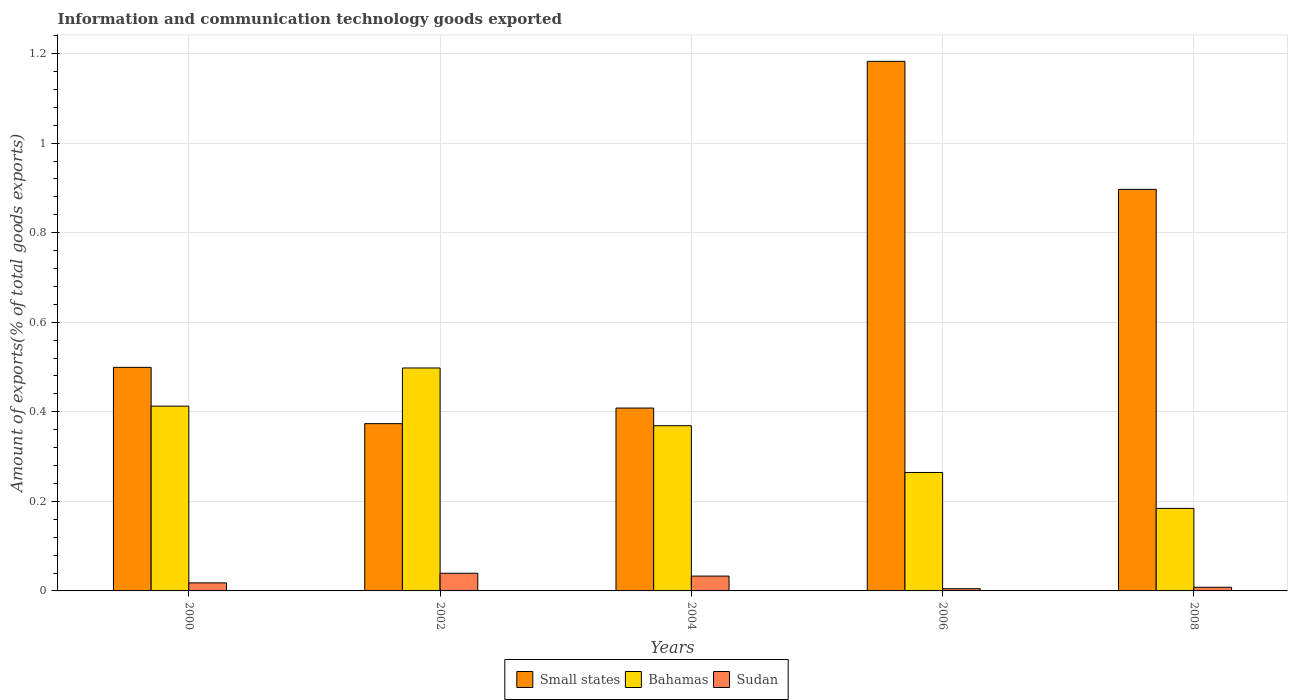Are the number of bars per tick equal to the number of legend labels?
Provide a short and direct response. Yes. In how many cases, is the number of bars for a given year not equal to the number of legend labels?
Provide a short and direct response. 0. What is the amount of goods exported in Small states in 2002?
Your response must be concise. 0.37. Across all years, what is the maximum amount of goods exported in Bahamas?
Give a very brief answer. 0.5. Across all years, what is the minimum amount of goods exported in Small states?
Give a very brief answer. 0.37. What is the total amount of goods exported in Small states in the graph?
Make the answer very short. 3.36. What is the difference between the amount of goods exported in Small states in 2002 and that in 2008?
Offer a terse response. -0.52. What is the difference between the amount of goods exported in Small states in 2000 and the amount of goods exported in Sudan in 2006?
Make the answer very short. 0.49. What is the average amount of goods exported in Sudan per year?
Ensure brevity in your answer.  0.02. In the year 2008, what is the difference between the amount of goods exported in Sudan and amount of goods exported in Small states?
Provide a succinct answer. -0.89. In how many years, is the amount of goods exported in Sudan greater than 0.6000000000000001 %?
Your answer should be compact. 0. What is the ratio of the amount of goods exported in Bahamas in 2000 to that in 2006?
Provide a short and direct response. 1.56. Is the amount of goods exported in Small states in 2000 less than that in 2008?
Your response must be concise. Yes. What is the difference between the highest and the second highest amount of goods exported in Bahamas?
Your answer should be compact. 0.09. What is the difference between the highest and the lowest amount of goods exported in Bahamas?
Your answer should be compact. 0.31. In how many years, is the amount of goods exported in Small states greater than the average amount of goods exported in Small states taken over all years?
Your response must be concise. 2. Is the sum of the amount of goods exported in Bahamas in 2002 and 2008 greater than the maximum amount of goods exported in Sudan across all years?
Offer a very short reply. Yes. What does the 1st bar from the left in 2004 represents?
Provide a short and direct response. Small states. What does the 2nd bar from the right in 2000 represents?
Offer a very short reply. Bahamas. Is it the case that in every year, the sum of the amount of goods exported in Sudan and amount of goods exported in Bahamas is greater than the amount of goods exported in Small states?
Provide a succinct answer. No. Are all the bars in the graph horizontal?
Your answer should be very brief. No. How many years are there in the graph?
Provide a short and direct response. 5. What is the difference between two consecutive major ticks on the Y-axis?
Your response must be concise. 0.2. Are the values on the major ticks of Y-axis written in scientific E-notation?
Keep it short and to the point. No. How are the legend labels stacked?
Keep it short and to the point. Horizontal. What is the title of the graph?
Your response must be concise. Information and communication technology goods exported. What is the label or title of the Y-axis?
Offer a terse response. Amount of exports(% of total goods exports). What is the Amount of exports(% of total goods exports) in Small states in 2000?
Your answer should be compact. 0.5. What is the Amount of exports(% of total goods exports) in Bahamas in 2000?
Provide a short and direct response. 0.41. What is the Amount of exports(% of total goods exports) in Sudan in 2000?
Offer a very short reply. 0.02. What is the Amount of exports(% of total goods exports) of Small states in 2002?
Offer a very short reply. 0.37. What is the Amount of exports(% of total goods exports) of Bahamas in 2002?
Give a very brief answer. 0.5. What is the Amount of exports(% of total goods exports) of Sudan in 2002?
Offer a very short reply. 0.04. What is the Amount of exports(% of total goods exports) of Small states in 2004?
Provide a succinct answer. 0.41. What is the Amount of exports(% of total goods exports) of Bahamas in 2004?
Provide a succinct answer. 0.37. What is the Amount of exports(% of total goods exports) of Sudan in 2004?
Offer a terse response. 0.03. What is the Amount of exports(% of total goods exports) of Small states in 2006?
Your answer should be compact. 1.18. What is the Amount of exports(% of total goods exports) in Bahamas in 2006?
Your answer should be very brief. 0.26. What is the Amount of exports(% of total goods exports) of Sudan in 2006?
Offer a terse response. 0. What is the Amount of exports(% of total goods exports) of Small states in 2008?
Provide a short and direct response. 0.9. What is the Amount of exports(% of total goods exports) of Bahamas in 2008?
Make the answer very short. 0.18. What is the Amount of exports(% of total goods exports) of Sudan in 2008?
Give a very brief answer. 0.01. Across all years, what is the maximum Amount of exports(% of total goods exports) in Small states?
Offer a terse response. 1.18. Across all years, what is the maximum Amount of exports(% of total goods exports) of Bahamas?
Offer a terse response. 0.5. Across all years, what is the maximum Amount of exports(% of total goods exports) in Sudan?
Keep it short and to the point. 0.04. Across all years, what is the minimum Amount of exports(% of total goods exports) in Small states?
Your answer should be very brief. 0.37. Across all years, what is the minimum Amount of exports(% of total goods exports) in Bahamas?
Your response must be concise. 0.18. Across all years, what is the minimum Amount of exports(% of total goods exports) of Sudan?
Ensure brevity in your answer.  0. What is the total Amount of exports(% of total goods exports) in Small states in the graph?
Offer a very short reply. 3.36. What is the total Amount of exports(% of total goods exports) of Bahamas in the graph?
Your answer should be very brief. 1.73. What is the total Amount of exports(% of total goods exports) of Sudan in the graph?
Provide a short and direct response. 0.1. What is the difference between the Amount of exports(% of total goods exports) of Small states in 2000 and that in 2002?
Ensure brevity in your answer.  0.13. What is the difference between the Amount of exports(% of total goods exports) of Bahamas in 2000 and that in 2002?
Offer a very short reply. -0.09. What is the difference between the Amount of exports(% of total goods exports) of Sudan in 2000 and that in 2002?
Ensure brevity in your answer.  -0.02. What is the difference between the Amount of exports(% of total goods exports) in Small states in 2000 and that in 2004?
Provide a short and direct response. 0.09. What is the difference between the Amount of exports(% of total goods exports) of Bahamas in 2000 and that in 2004?
Keep it short and to the point. 0.04. What is the difference between the Amount of exports(% of total goods exports) in Sudan in 2000 and that in 2004?
Ensure brevity in your answer.  -0.02. What is the difference between the Amount of exports(% of total goods exports) in Small states in 2000 and that in 2006?
Ensure brevity in your answer.  -0.68. What is the difference between the Amount of exports(% of total goods exports) in Bahamas in 2000 and that in 2006?
Make the answer very short. 0.15. What is the difference between the Amount of exports(% of total goods exports) of Sudan in 2000 and that in 2006?
Keep it short and to the point. 0.01. What is the difference between the Amount of exports(% of total goods exports) of Small states in 2000 and that in 2008?
Your response must be concise. -0.4. What is the difference between the Amount of exports(% of total goods exports) in Bahamas in 2000 and that in 2008?
Provide a succinct answer. 0.23. What is the difference between the Amount of exports(% of total goods exports) of Sudan in 2000 and that in 2008?
Make the answer very short. 0.01. What is the difference between the Amount of exports(% of total goods exports) in Small states in 2002 and that in 2004?
Offer a very short reply. -0.03. What is the difference between the Amount of exports(% of total goods exports) of Bahamas in 2002 and that in 2004?
Offer a very short reply. 0.13. What is the difference between the Amount of exports(% of total goods exports) in Sudan in 2002 and that in 2004?
Your answer should be very brief. 0.01. What is the difference between the Amount of exports(% of total goods exports) in Small states in 2002 and that in 2006?
Provide a succinct answer. -0.81. What is the difference between the Amount of exports(% of total goods exports) of Bahamas in 2002 and that in 2006?
Offer a very short reply. 0.23. What is the difference between the Amount of exports(% of total goods exports) in Sudan in 2002 and that in 2006?
Provide a short and direct response. 0.03. What is the difference between the Amount of exports(% of total goods exports) of Small states in 2002 and that in 2008?
Offer a terse response. -0.52. What is the difference between the Amount of exports(% of total goods exports) in Bahamas in 2002 and that in 2008?
Keep it short and to the point. 0.31. What is the difference between the Amount of exports(% of total goods exports) of Sudan in 2002 and that in 2008?
Keep it short and to the point. 0.03. What is the difference between the Amount of exports(% of total goods exports) in Small states in 2004 and that in 2006?
Make the answer very short. -0.77. What is the difference between the Amount of exports(% of total goods exports) of Bahamas in 2004 and that in 2006?
Offer a terse response. 0.1. What is the difference between the Amount of exports(% of total goods exports) in Sudan in 2004 and that in 2006?
Offer a terse response. 0.03. What is the difference between the Amount of exports(% of total goods exports) of Small states in 2004 and that in 2008?
Provide a short and direct response. -0.49. What is the difference between the Amount of exports(% of total goods exports) of Bahamas in 2004 and that in 2008?
Offer a very short reply. 0.18. What is the difference between the Amount of exports(% of total goods exports) of Sudan in 2004 and that in 2008?
Offer a very short reply. 0.03. What is the difference between the Amount of exports(% of total goods exports) of Small states in 2006 and that in 2008?
Offer a very short reply. 0.29. What is the difference between the Amount of exports(% of total goods exports) in Bahamas in 2006 and that in 2008?
Offer a very short reply. 0.08. What is the difference between the Amount of exports(% of total goods exports) in Sudan in 2006 and that in 2008?
Offer a terse response. -0. What is the difference between the Amount of exports(% of total goods exports) in Small states in 2000 and the Amount of exports(% of total goods exports) in Bahamas in 2002?
Your response must be concise. 0. What is the difference between the Amount of exports(% of total goods exports) of Small states in 2000 and the Amount of exports(% of total goods exports) of Sudan in 2002?
Make the answer very short. 0.46. What is the difference between the Amount of exports(% of total goods exports) of Bahamas in 2000 and the Amount of exports(% of total goods exports) of Sudan in 2002?
Offer a very short reply. 0.37. What is the difference between the Amount of exports(% of total goods exports) of Small states in 2000 and the Amount of exports(% of total goods exports) of Bahamas in 2004?
Your response must be concise. 0.13. What is the difference between the Amount of exports(% of total goods exports) in Small states in 2000 and the Amount of exports(% of total goods exports) in Sudan in 2004?
Keep it short and to the point. 0.47. What is the difference between the Amount of exports(% of total goods exports) in Bahamas in 2000 and the Amount of exports(% of total goods exports) in Sudan in 2004?
Ensure brevity in your answer.  0.38. What is the difference between the Amount of exports(% of total goods exports) of Small states in 2000 and the Amount of exports(% of total goods exports) of Bahamas in 2006?
Ensure brevity in your answer.  0.23. What is the difference between the Amount of exports(% of total goods exports) of Small states in 2000 and the Amount of exports(% of total goods exports) of Sudan in 2006?
Provide a succinct answer. 0.49. What is the difference between the Amount of exports(% of total goods exports) in Bahamas in 2000 and the Amount of exports(% of total goods exports) in Sudan in 2006?
Give a very brief answer. 0.41. What is the difference between the Amount of exports(% of total goods exports) in Small states in 2000 and the Amount of exports(% of total goods exports) in Bahamas in 2008?
Your answer should be very brief. 0.32. What is the difference between the Amount of exports(% of total goods exports) of Small states in 2000 and the Amount of exports(% of total goods exports) of Sudan in 2008?
Your answer should be compact. 0.49. What is the difference between the Amount of exports(% of total goods exports) of Bahamas in 2000 and the Amount of exports(% of total goods exports) of Sudan in 2008?
Provide a succinct answer. 0.4. What is the difference between the Amount of exports(% of total goods exports) in Small states in 2002 and the Amount of exports(% of total goods exports) in Bahamas in 2004?
Offer a terse response. 0. What is the difference between the Amount of exports(% of total goods exports) in Small states in 2002 and the Amount of exports(% of total goods exports) in Sudan in 2004?
Provide a succinct answer. 0.34. What is the difference between the Amount of exports(% of total goods exports) of Bahamas in 2002 and the Amount of exports(% of total goods exports) of Sudan in 2004?
Your answer should be very brief. 0.46. What is the difference between the Amount of exports(% of total goods exports) in Small states in 2002 and the Amount of exports(% of total goods exports) in Bahamas in 2006?
Provide a short and direct response. 0.11. What is the difference between the Amount of exports(% of total goods exports) in Small states in 2002 and the Amount of exports(% of total goods exports) in Sudan in 2006?
Offer a very short reply. 0.37. What is the difference between the Amount of exports(% of total goods exports) of Bahamas in 2002 and the Amount of exports(% of total goods exports) of Sudan in 2006?
Provide a short and direct response. 0.49. What is the difference between the Amount of exports(% of total goods exports) of Small states in 2002 and the Amount of exports(% of total goods exports) of Bahamas in 2008?
Make the answer very short. 0.19. What is the difference between the Amount of exports(% of total goods exports) in Small states in 2002 and the Amount of exports(% of total goods exports) in Sudan in 2008?
Offer a very short reply. 0.37. What is the difference between the Amount of exports(% of total goods exports) of Bahamas in 2002 and the Amount of exports(% of total goods exports) of Sudan in 2008?
Your answer should be very brief. 0.49. What is the difference between the Amount of exports(% of total goods exports) in Small states in 2004 and the Amount of exports(% of total goods exports) in Bahamas in 2006?
Provide a short and direct response. 0.14. What is the difference between the Amount of exports(% of total goods exports) of Small states in 2004 and the Amount of exports(% of total goods exports) of Sudan in 2006?
Give a very brief answer. 0.4. What is the difference between the Amount of exports(% of total goods exports) of Bahamas in 2004 and the Amount of exports(% of total goods exports) of Sudan in 2006?
Your response must be concise. 0.36. What is the difference between the Amount of exports(% of total goods exports) of Small states in 2004 and the Amount of exports(% of total goods exports) of Bahamas in 2008?
Keep it short and to the point. 0.22. What is the difference between the Amount of exports(% of total goods exports) in Small states in 2004 and the Amount of exports(% of total goods exports) in Sudan in 2008?
Ensure brevity in your answer.  0.4. What is the difference between the Amount of exports(% of total goods exports) in Bahamas in 2004 and the Amount of exports(% of total goods exports) in Sudan in 2008?
Offer a terse response. 0.36. What is the difference between the Amount of exports(% of total goods exports) in Small states in 2006 and the Amount of exports(% of total goods exports) in Sudan in 2008?
Offer a terse response. 1.17. What is the difference between the Amount of exports(% of total goods exports) of Bahamas in 2006 and the Amount of exports(% of total goods exports) of Sudan in 2008?
Ensure brevity in your answer.  0.26. What is the average Amount of exports(% of total goods exports) of Small states per year?
Provide a short and direct response. 0.67. What is the average Amount of exports(% of total goods exports) of Bahamas per year?
Make the answer very short. 0.35. What is the average Amount of exports(% of total goods exports) of Sudan per year?
Make the answer very short. 0.02. In the year 2000, what is the difference between the Amount of exports(% of total goods exports) of Small states and Amount of exports(% of total goods exports) of Bahamas?
Your answer should be very brief. 0.09. In the year 2000, what is the difference between the Amount of exports(% of total goods exports) of Small states and Amount of exports(% of total goods exports) of Sudan?
Provide a short and direct response. 0.48. In the year 2000, what is the difference between the Amount of exports(% of total goods exports) in Bahamas and Amount of exports(% of total goods exports) in Sudan?
Provide a succinct answer. 0.39. In the year 2002, what is the difference between the Amount of exports(% of total goods exports) of Small states and Amount of exports(% of total goods exports) of Bahamas?
Your answer should be compact. -0.12. In the year 2002, what is the difference between the Amount of exports(% of total goods exports) in Small states and Amount of exports(% of total goods exports) in Sudan?
Give a very brief answer. 0.33. In the year 2002, what is the difference between the Amount of exports(% of total goods exports) in Bahamas and Amount of exports(% of total goods exports) in Sudan?
Provide a succinct answer. 0.46. In the year 2004, what is the difference between the Amount of exports(% of total goods exports) of Small states and Amount of exports(% of total goods exports) of Bahamas?
Make the answer very short. 0.04. In the year 2004, what is the difference between the Amount of exports(% of total goods exports) in Small states and Amount of exports(% of total goods exports) in Sudan?
Give a very brief answer. 0.38. In the year 2004, what is the difference between the Amount of exports(% of total goods exports) of Bahamas and Amount of exports(% of total goods exports) of Sudan?
Your response must be concise. 0.34. In the year 2006, what is the difference between the Amount of exports(% of total goods exports) of Small states and Amount of exports(% of total goods exports) of Bahamas?
Offer a very short reply. 0.92. In the year 2006, what is the difference between the Amount of exports(% of total goods exports) of Small states and Amount of exports(% of total goods exports) of Sudan?
Ensure brevity in your answer.  1.18. In the year 2006, what is the difference between the Amount of exports(% of total goods exports) in Bahamas and Amount of exports(% of total goods exports) in Sudan?
Your answer should be very brief. 0.26. In the year 2008, what is the difference between the Amount of exports(% of total goods exports) of Small states and Amount of exports(% of total goods exports) of Bahamas?
Give a very brief answer. 0.71. In the year 2008, what is the difference between the Amount of exports(% of total goods exports) in Small states and Amount of exports(% of total goods exports) in Sudan?
Offer a terse response. 0.89. In the year 2008, what is the difference between the Amount of exports(% of total goods exports) in Bahamas and Amount of exports(% of total goods exports) in Sudan?
Provide a succinct answer. 0.18. What is the ratio of the Amount of exports(% of total goods exports) of Small states in 2000 to that in 2002?
Offer a terse response. 1.34. What is the ratio of the Amount of exports(% of total goods exports) in Bahamas in 2000 to that in 2002?
Provide a succinct answer. 0.83. What is the ratio of the Amount of exports(% of total goods exports) in Sudan in 2000 to that in 2002?
Your answer should be very brief. 0.46. What is the ratio of the Amount of exports(% of total goods exports) of Small states in 2000 to that in 2004?
Offer a terse response. 1.22. What is the ratio of the Amount of exports(% of total goods exports) of Bahamas in 2000 to that in 2004?
Provide a short and direct response. 1.12. What is the ratio of the Amount of exports(% of total goods exports) of Sudan in 2000 to that in 2004?
Your answer should be very brief. 0.54. What is the ratio of the Amount of exports(% of total goods exports) in Small states in 2000 to that in 2006?
Ensure brevity in your answer.  0.42. What is the ratio of the Amount of exports(% of total goods exports) of Bahamas in 2000 to that in 2006?
Your response must be concise. 1.56. What is the ratio of the Amount of exports(% of total goods exports) of Sudan in 2000 to that in 2006?
Make the answer very short. 3.62. What is the ratio of the Amount of exports(% of total goods exports) in Small states in 2000 to that in 2008?
Make the answer very short. 0.56. What is the ratio of the Amount of exports(% of total goods exports) of Bahamas in 2000 to that in 2008?
Ensure brevity in your answer.  2.24. What is the ratio of the Amount of exports(% of total goods exports) of Sudan in 2000 to that in 2008?
Ensure brevity in your answer.  2.2. What is the ratio of the Amount of exports(% of total goods exports) in Small states in 2002 to that in 2004?
Give a very brief answer. 0.91. What is the ratio of the Amount of exports(% of total goods exports) in Bahamas in 2002 to that in 2004?
Provide a short and direct response. 1.35. What is the ratio of the Amount of exports(% of total goods exports) in Sudan in 2002 to that in 2004?
Your answer should be compact. 1.19. What is the ratio of the Amount of exports(% of total goods exports) in Small states in 2002 to that in 2006?
Offer a very short reply. 0.32. What is the ratio of the Amount of exports(% of total goods exports) of Bahamas in 2002 to that in 2006?
Offer a very short reply. 1.88. What is the ratio of the Amount of exports(% of total goods exports) of Sudan in 2002 to that in 2006?
Make the answer very short. 7.96. What is the ratio of the Amount of exports(% of total goods exports) of Small states in 2002 to that in 2008?
Offer a very short reply. 0.42. What is the ratio of the Amount of exports(% of total goods exports) in Bahamas in 2002 to that in 2008?
Make the answer very short. 2.7. What is the ratio of the Amount of exports(% of total goods exports) of Sudan in 2002 to that in 2008?
Provide a short and direct response. 4.84. What is the ratio of the Amount of exports(% of total goods exports) in Small states in 2004 to that in 2006?
Keep it short and to the point. 0.35. What is the ratio of the Amount of exports(% of total goods exports) of Bahamas in 2004 to that in 2006?
Offer a terse response. 1.39. What is the ratio of the Amount of exports(% of total goods exports) in Sudan in 2004 to that in 2006?
Provide a short and direct response. 6.68. What is the ratio of the Amount of exports(% of total goods exports) of Small states in 2004 to that in 2008?
Keep it short and to the point. 0.46. What is the ratio of the Amount of exports(% of total goods exports) in Bahamas in 2004 to that in 2008?
Provide a succinct answer. 2. What is the ratio of the Amount of exports(% of total goods exports) of Sudan in 2004 to that in 2008?
Make the answer very short. 4.06. What is the ratio of the Amount of exports(% of total goods exports) in Small states in 2006 to that in 2008?
Your answer should be very brief. 1.32. What is the ratio of the Amount of exports(% of total goods exports) in Bahamas in 2006 to that in 2008?
Your answer should be very brief. 1.44. What is the ratio of the Amount of exports(% of total goods exports) of Sudan in 2006 to that in 2008?
Give a very brief answer. 0.61. What is the difference between the highest and the second highest Amount of exports(% of total goods exports) in Small states?
Offer a terse response. 0.29. What is the difference between the highest and the second highest Amount of exports(% of total goods exports) of Bahamas?
Give a very brief answer. 0.09. What is the difference between the highest and the second highest Amount of exports(% of total goods exports) in Sudan?
Ensure brevity in your answer.  0.01. What is the difference between the highest and the lowest Amount of exports(% of total goods exports) in Small states?
Offer a terse response. 0.81. What is the difference between the highest and the lowest Amount of exports(% of total goods exports) in Bahamas?
Your answer should be very brief. 0.31. What is the difference between the highest and the lowest Amount of exports(% of total goods exports) of Sudan?
Your answer should be very brief. 0.03. 